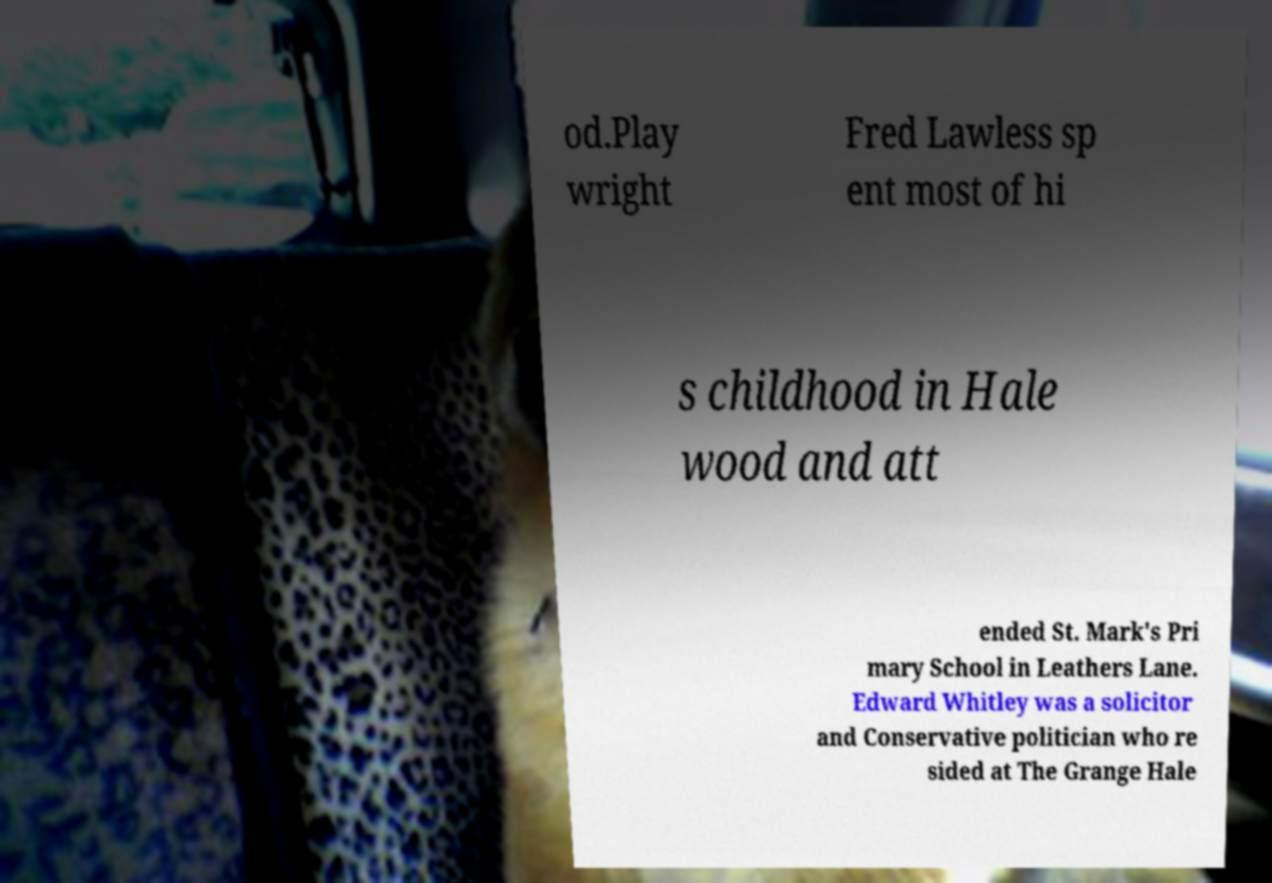For documentation purposes, I need the text within this image transcribed. Could you provide that? od.Play wright Fred Lawless sp ent most of hi s childhood in Hale wood and att ended St. Mark's Pri mary School in Leathers Lane. Edward Whitley was a solicitor and Conservative politician who re sided at The Grange Hale 